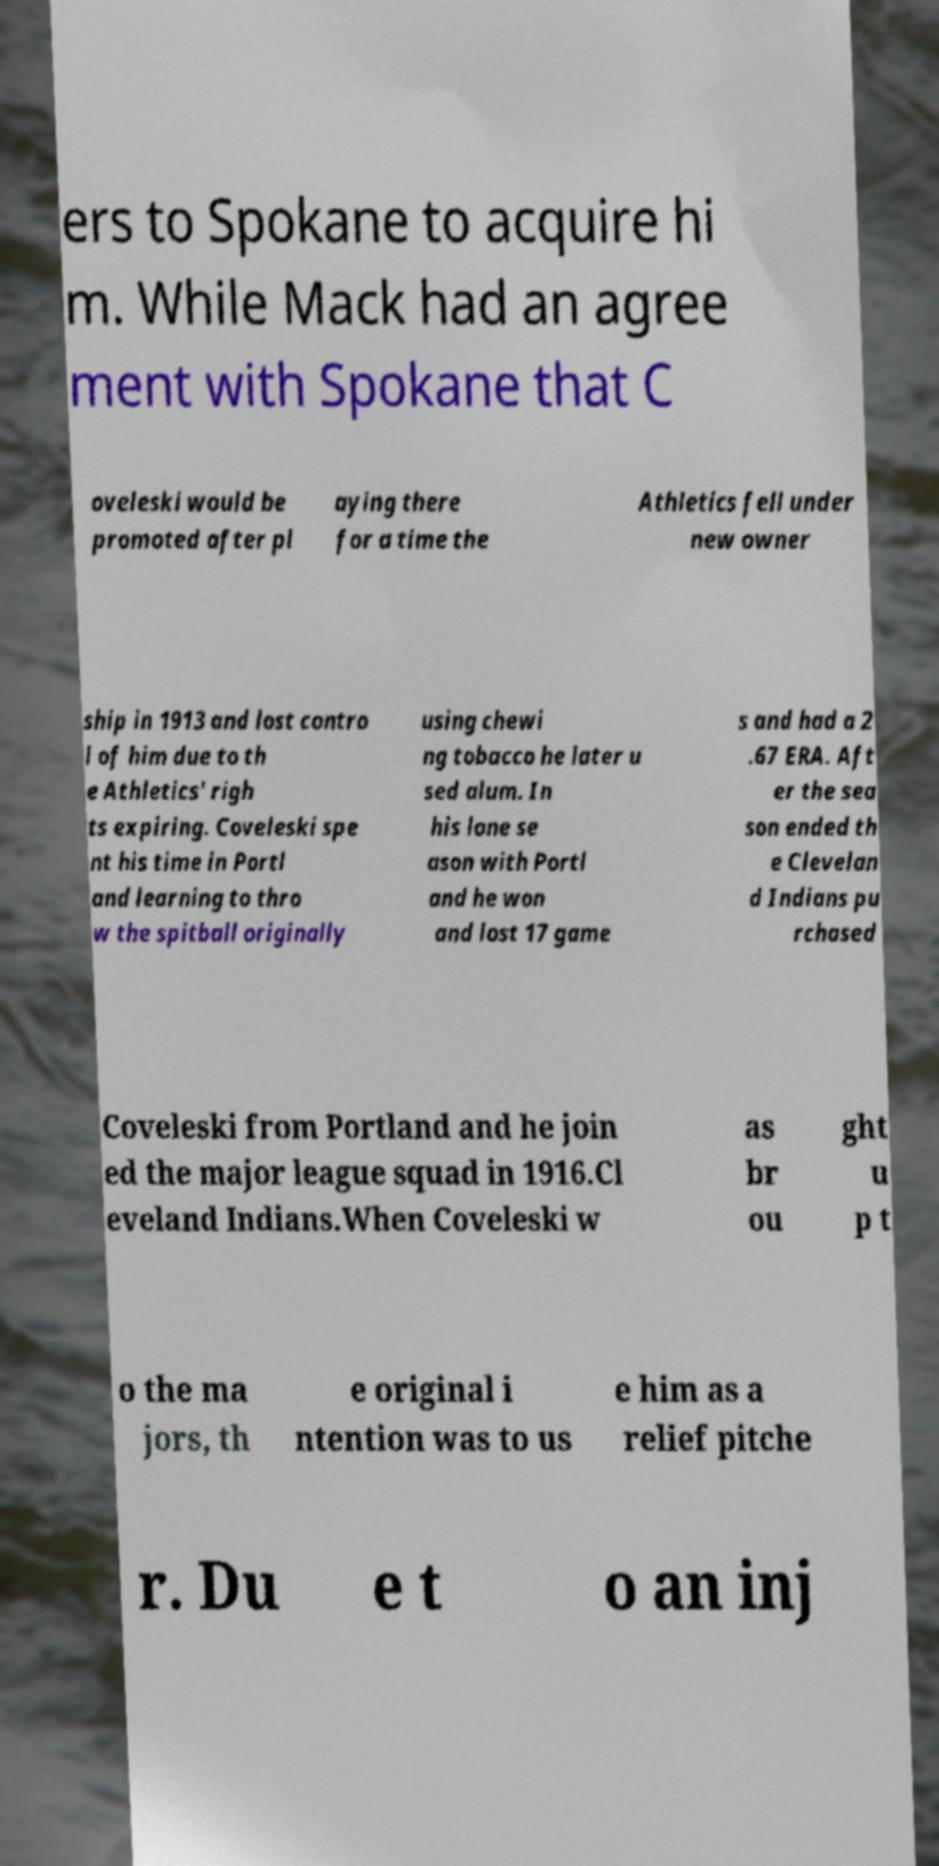There's text embedded in this image that I need extracted. Can you transcribe it verbatim? ers to Spokane to acquire hi m. While Mack had an agree ment with Spokane that C oveleski would be promoted after pl aying there for a time the Athletics fell under new owner ship in 1913 and lost contro l of him due to th e Athletics' righ ts expiring. Coveleski spe nt his time in Portl and learning to thro w the spitball originally using chewi ng tobacco he later u sed alum. In his lone se ason with Portl and he won and lost 17 game s and had a 2 .67 ERA. Aft er the sea son ended th e Clevelan d Indians pu rchased Coveleski from Portland and he join ed the major league squad in 1916.Cl eveland Indians.When Coveleski w as br ou ght u p t o the ma jors, th e original i ntention was to us e him as a relief pitche r. Du e t o an inj 